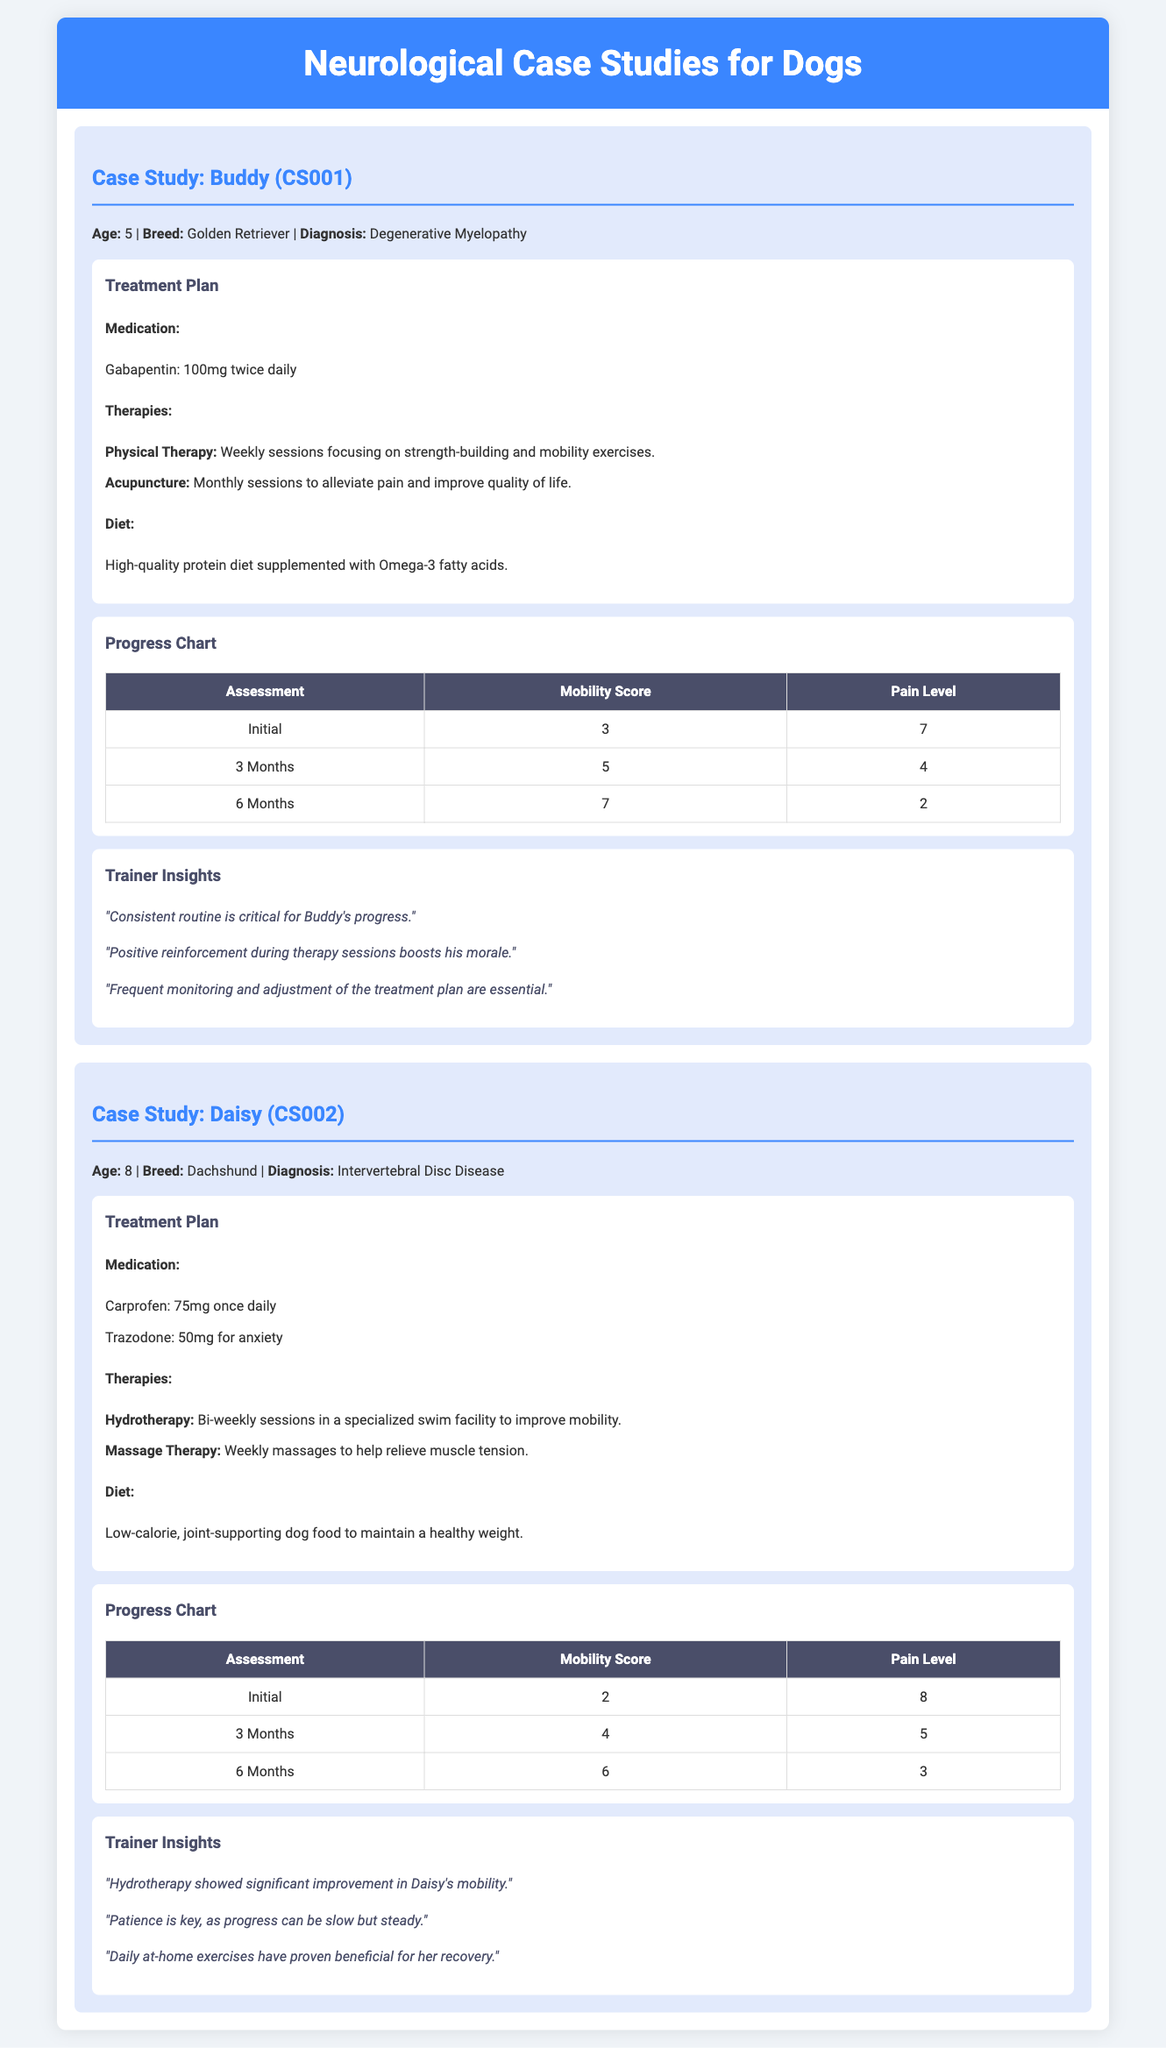What is Buddy's diagnosis? Buddy is diagnosed with Degenerative Myelopathy, which is stated in his case study.
Answer: Degenerative Myelopathy How often does Daisy receive hydrotherapy sessions? Daisy's treatment plan specifies bi-weekly sessions for hydrotherapy.
Answer: Bi-weekly What medication is Buddy taking? The document lists Gabapentin as the medication Buddy is taking.
Answer: Gabapentin What was Daisy's initial mobility score? The progress chart shows that Daisy's initial mobility score was 2.
Answer: 2 How long is Buddy's treatment plan focused on physical therapy? Buddy's treatment plan mentions weekly sessions, indicating a long-term approach.
Answer: Weekly What is the pain level of Buddy after 6 months? The progress chart indicates that Buddy's pain level after 6 months is 2.
Answer: 2 What type of therapy does Daisy receive weekly? Daisy's treatment plan includes weekly massages to relieve muscle tension.
Answer: Massage Therapy What key insight does Buddy's trainer emphasize? A key insight from Buddy's trainer is that consistent routine is critical for progress.
Answer: Consistent routine What type of diet is recommended for Daisy? Daisy's diet plan suggests low-calorie, joint-supporting dog food.
Answer: Low-calorie, joint-supporting dog food 